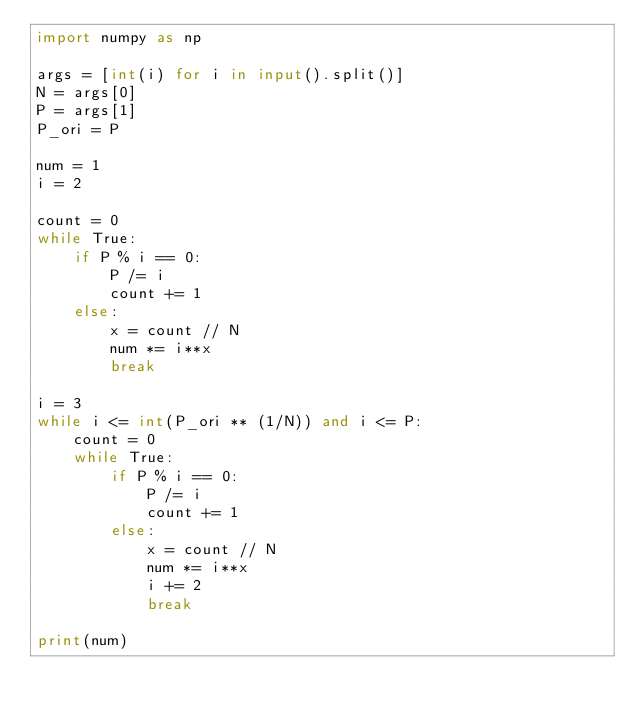Convert code to text. <code><loc_0><loc_0><loc_500><loc_500><_Python_>import numpy as np

args = [int(i) for i in input().split()]
N = args[0]
P = args[1]
P_ori = P

num = 1
i = 2

count = 0
while True:
    if P % i == 0:
        P /= i
        count += 1
    else:
        x = count // N
        num *= i**x
        break

i = 3
while i <= int(P_ori ** (1/N)) and i <= P:
    count = 0
    while True:
        if P % i == 0:
            P /= i
            count += 1
        else:
            x = count // N
            num *= i**x
            i += 2
            break

print(num)</code> 